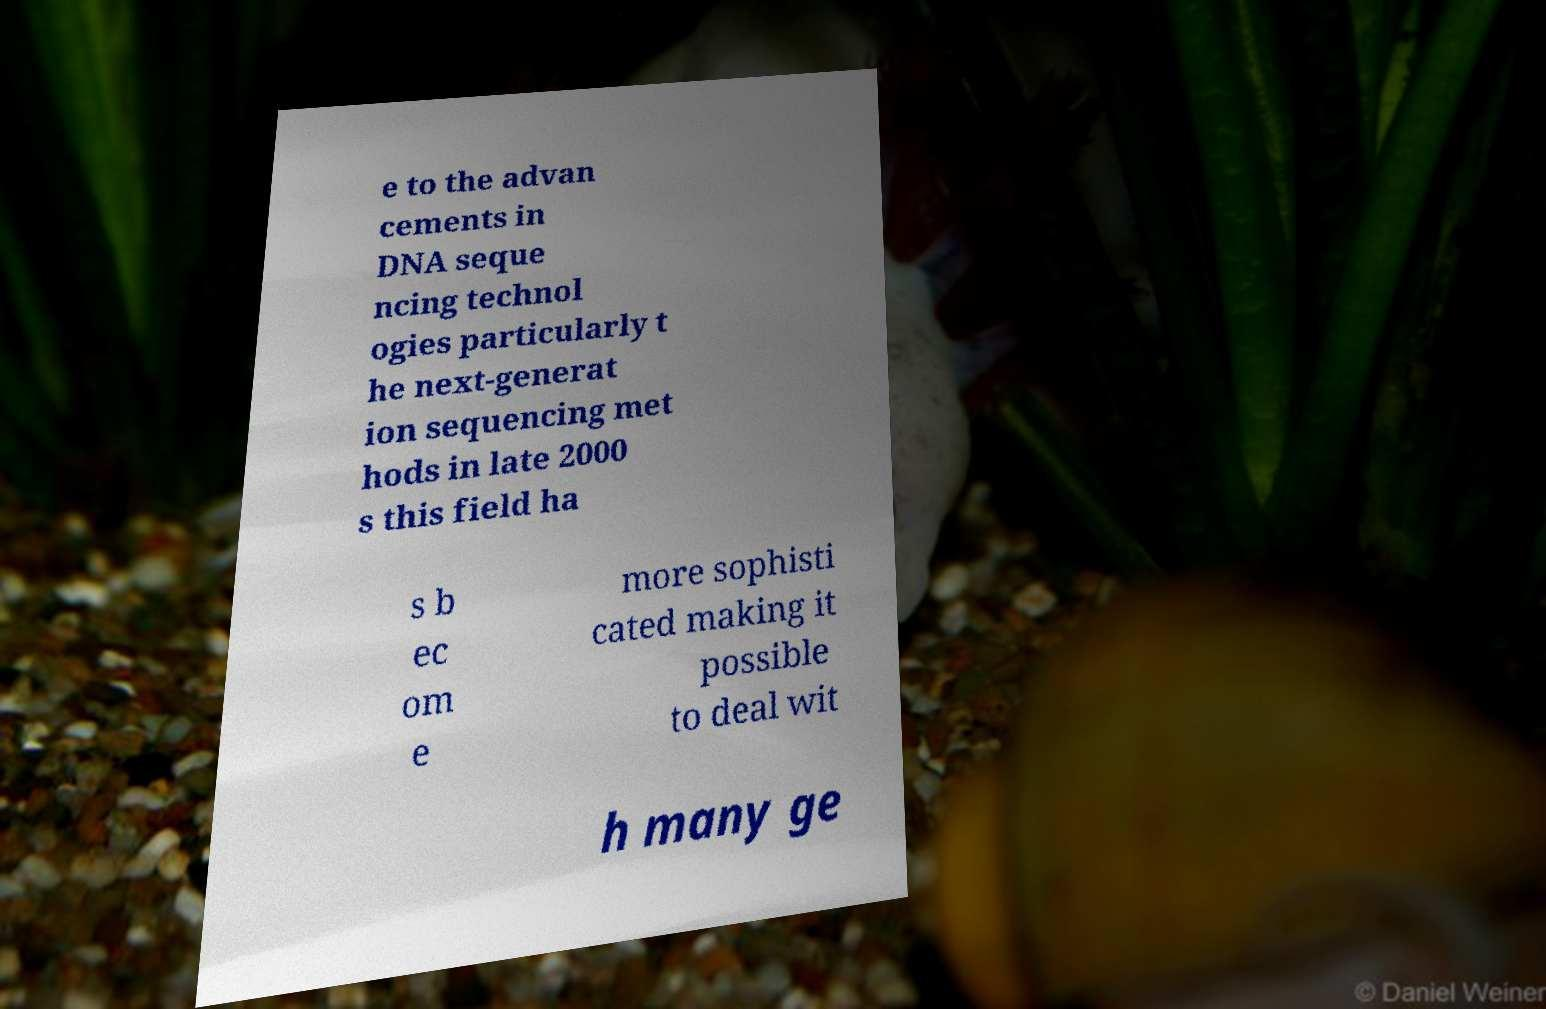Can you accurately transcribe the text from the provided image for me? e to the advan cements in DNA seque ncing technol ogies particularly t he next-generat ion sequencing met hods in late 2000 s this field ha s b ec om e more sophisti cated making it possible to deal wit h many ge 